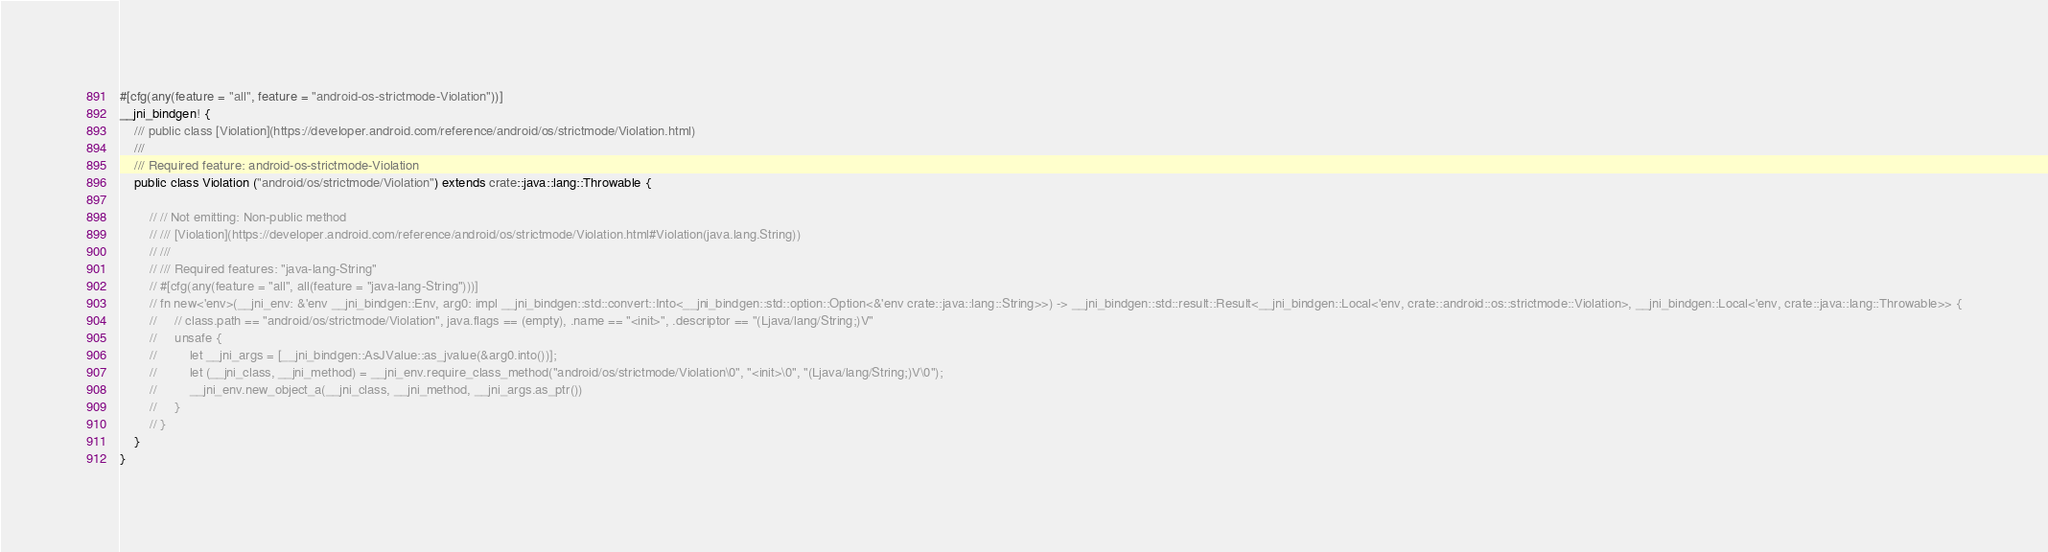Convert code to text. <code><loc_0><loc_0><loc_500><loc_500><_Rust_>

#[cfg(any(feature = "all", feature = "android-os-strictmode-Violation"))]
__jni_bindgen! {
    /// public class [Violation](https://developer.android.com/reference/android/os/strictmode/Violation.html)
    ///
    /// Required feature: android-os-strictmode-Violation
    public class Violation ("android/os/strictmode/Violation") extends crate::java::lang::Throwable {

        // // Not emitting: Non-public method
        // /// [Violation](https://developer.android.com/reference/android/os/strictmode/Violation.html#Violation(java.lang.String))
        // ///
        // /// Required features: "java-lang-String"
        // #[cfg(any(feature = "all", all(feature = "java-lang-String")))]
        // fn new<'env>(__jni_env: &'env __jni_bindgen::Env, arg0: impl __jni_bindgen::std::convert::Into<__jni_bindgen::std::option::Option<&'env crate::java::lang::String>>) -> __jni_bindgen::std::result::Result<__jni_bindgen::Local<'env, crate::android::os::strictmode::Violation>, __jni_bindgen::Local<'env, crate::java::lang::Throwable>> {
        //     // class.path == "android/os/strictmode/Violation", java.flags == (empty), .name == "<init>", .descriptor == "(Ljava/lang/String;)V"
        //     unsafe {
        //         let __jni_args = [__jni_bindgen::AsJValue::as_jvalue(&arg0.into())];
        //         let (__jni_class, __jni_method) = __jni_env.require_class_method("android/os/strictmode/Violation\0", "<init>\0", "(Ljava/lang/String;)V\0");
        //         __jni_env.new_object_a(__jni_class, __jni_method, __jni_args.as_ptr())
        //     }
        // }
    }
}
</code> 